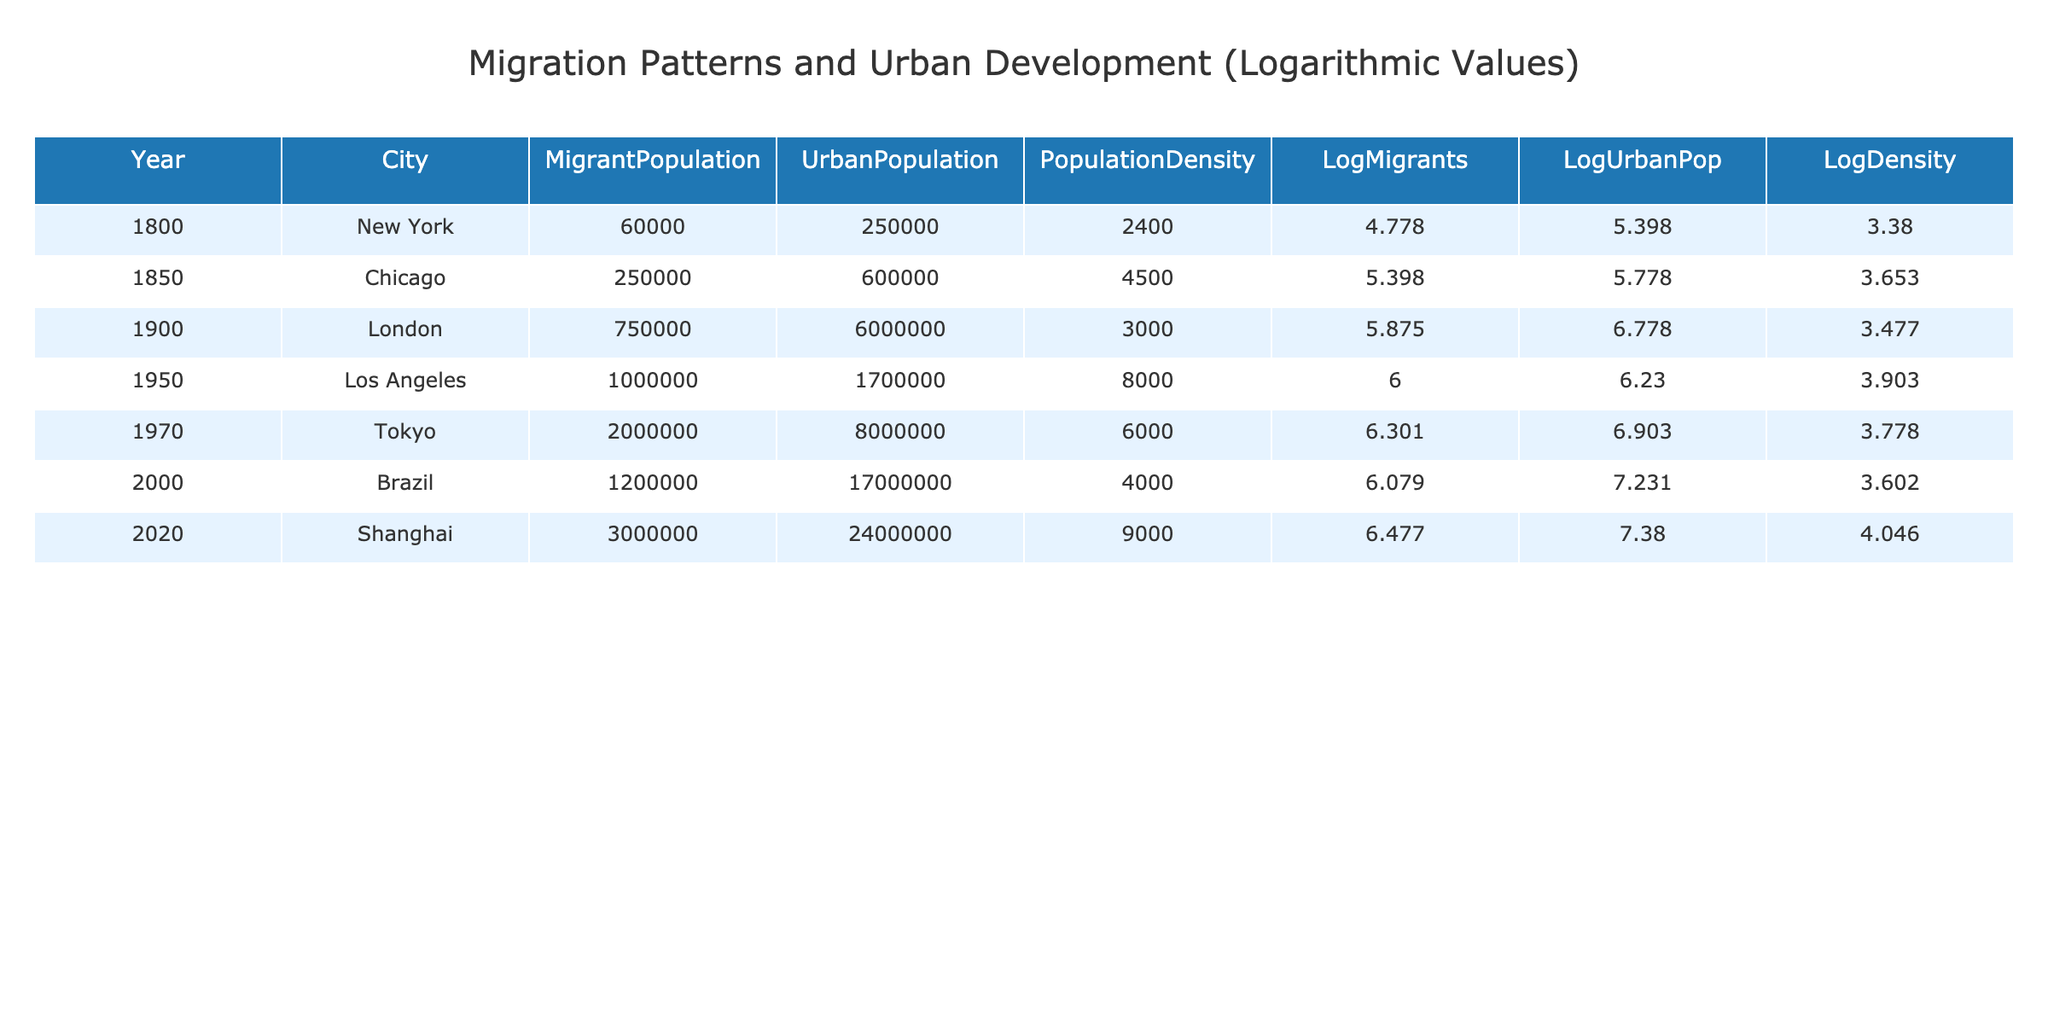What was the migrant population in New York in 1800? The table lists New York's migrant population in the year 1800, and the value is directly provided under the 'MigrantPopulation' column.
Answer: 60000 What is the population density of Tokyo in 1970? The table shows Tokyo's population density for the year 1970, which can be found directly in the 'PopulationDensity' column.
Answer: 6000 Which city had the highest migrant population between 1850 and 2020? By examining the 'MigrantPopulation' column for the years between 1850 and 2020, Shanghai has the highest value of 3000000 in 2020.
Answer: Shanghai Is the urban population in London greater than that in Los Angeles in 1950? Comparing the 'UrbanPopulation' values in the table, London had 6000000 in 1900 and Los Angeles had 1700000 in 1950. London’s population is clearly greater.
Answer: Yes What is the difference in migrant population between Chicago in 1850 and Los Angeles in 1950? The migrant population in Chicago for 1850 is 250000 and in Los Angeles for 1950 it is 1000000. The difference is calculated as 1000000 - 250000 = 750000.
Answer: 750000 What is the average urban population over the years listed in the table? First, we identify the urban populations: 250000, 600000, 6000000, 1700000, 8000000, 17000000, and 24000000. The total is 40000000 and the average is 40000000 divided by the 7 years, which equals approximately 5714285.71.
Answer: 5714285.71 Was the urban population in 2000 higher than the population density in 1800? The urban population in Brazil for 2000 is 17000000 and the population density in New York for 1800 is 2400. It is clear that 17000000 is greater than 2400.
Answer: Yes What trend can be observed in the migrant populations from 1800 to 2020? Looking at the 'MigrantPopulation' column, there is a consistent increase in the numbers for each successive entry, indicating a rising trend in migration over the years.
Answer: Increasing trend How does the logarithmic value of migrant population change from 1800 to 2020? Observing the 'LogMigrants' column shows the values: 4.778 (1800), 5.398 (1850), 5.875 (1900), 6.000 (1950), 6.301 (1970), 6.079 (2000), 6.477 (2020). This indicates an overall upward trend in the logarithmic values.
Answer: Upward trend 